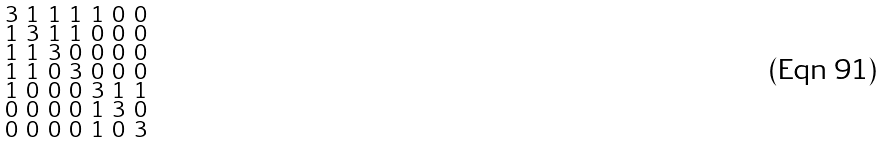Convert formula to latex. <formula><loc_0><loc_0><loc_500><loc_500>\begin{smallmatrix} 3 & 1 & 1 & 1 & 1 & 0 & 0 \\ 1 & 3 & 1 & 1 & 0 & 0 & 0 \\ 1 & 1 & 3 & 0 & 0 & 0 & 0 \\ 1 & 1 & 0 & 3 & 0 & 0 & 0 \\ 1 & 0 & 0 & 0 & 3 & 1 & 1 \\ 0 & 0 & 0 & 0 & 1 & 3 & 0 \\ 0 & 0 & 0 & 0 & 1 & 0 & 3 \end{smallmatrix}</formula> 